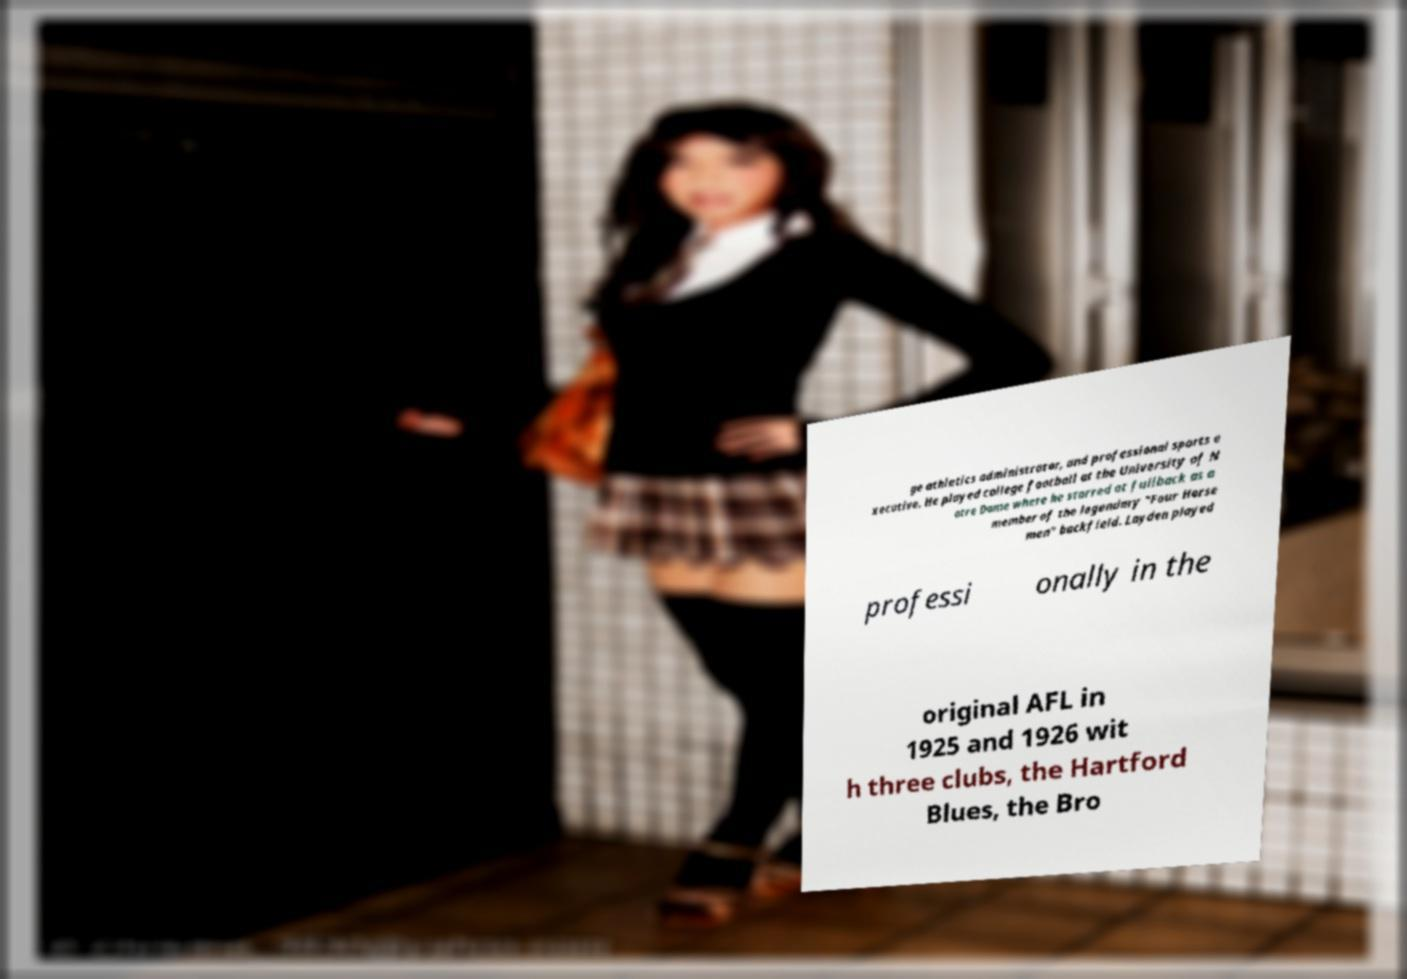Please identify and transcribe the text found in this image. ge athletics administrator, and professional sports e xecutive. He played college football at the University of N otre Dame where he starred at fullback as a member of the legendary "Four Horse men" backfield. Layden played professi onally in the original AFL in 1925 and 1926 wit h three clubs, the Hartford Blues, the Bro 